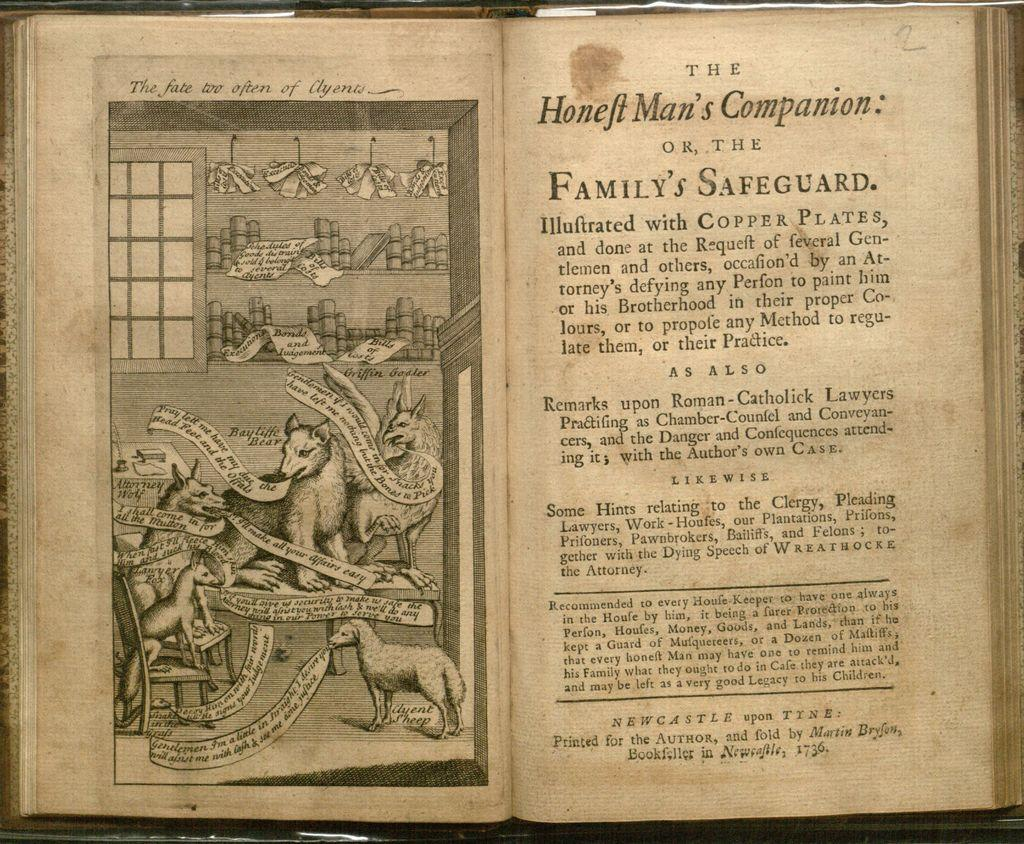<image>
Write a terse but informative summary of the picture. a book open to a story called 'the honeft mans's companion' 